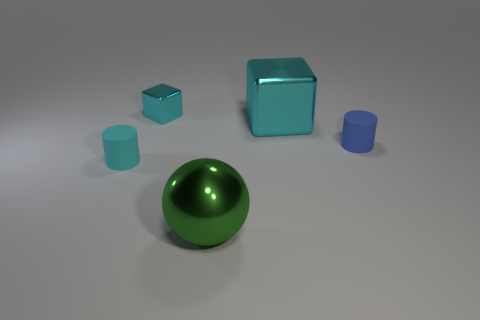Add 4 large green metal spheres. How many objects exist? 9 Subtract all cubes. How many objects are left? 3 Subtract 0 green blocks. How many objects are left? 5 Subtract all red cylinders. Subtract all brown cubes. How many cylinders are left? 2 Subtract all small cyan matte cylinders. Subtract all small brown blocks. How many objects are left? 4 Add 1 tiny cyan metal cubes. How many tiny cyan metal cubes are left? 2 Add 2 cubes. How many cubes exist? 4 